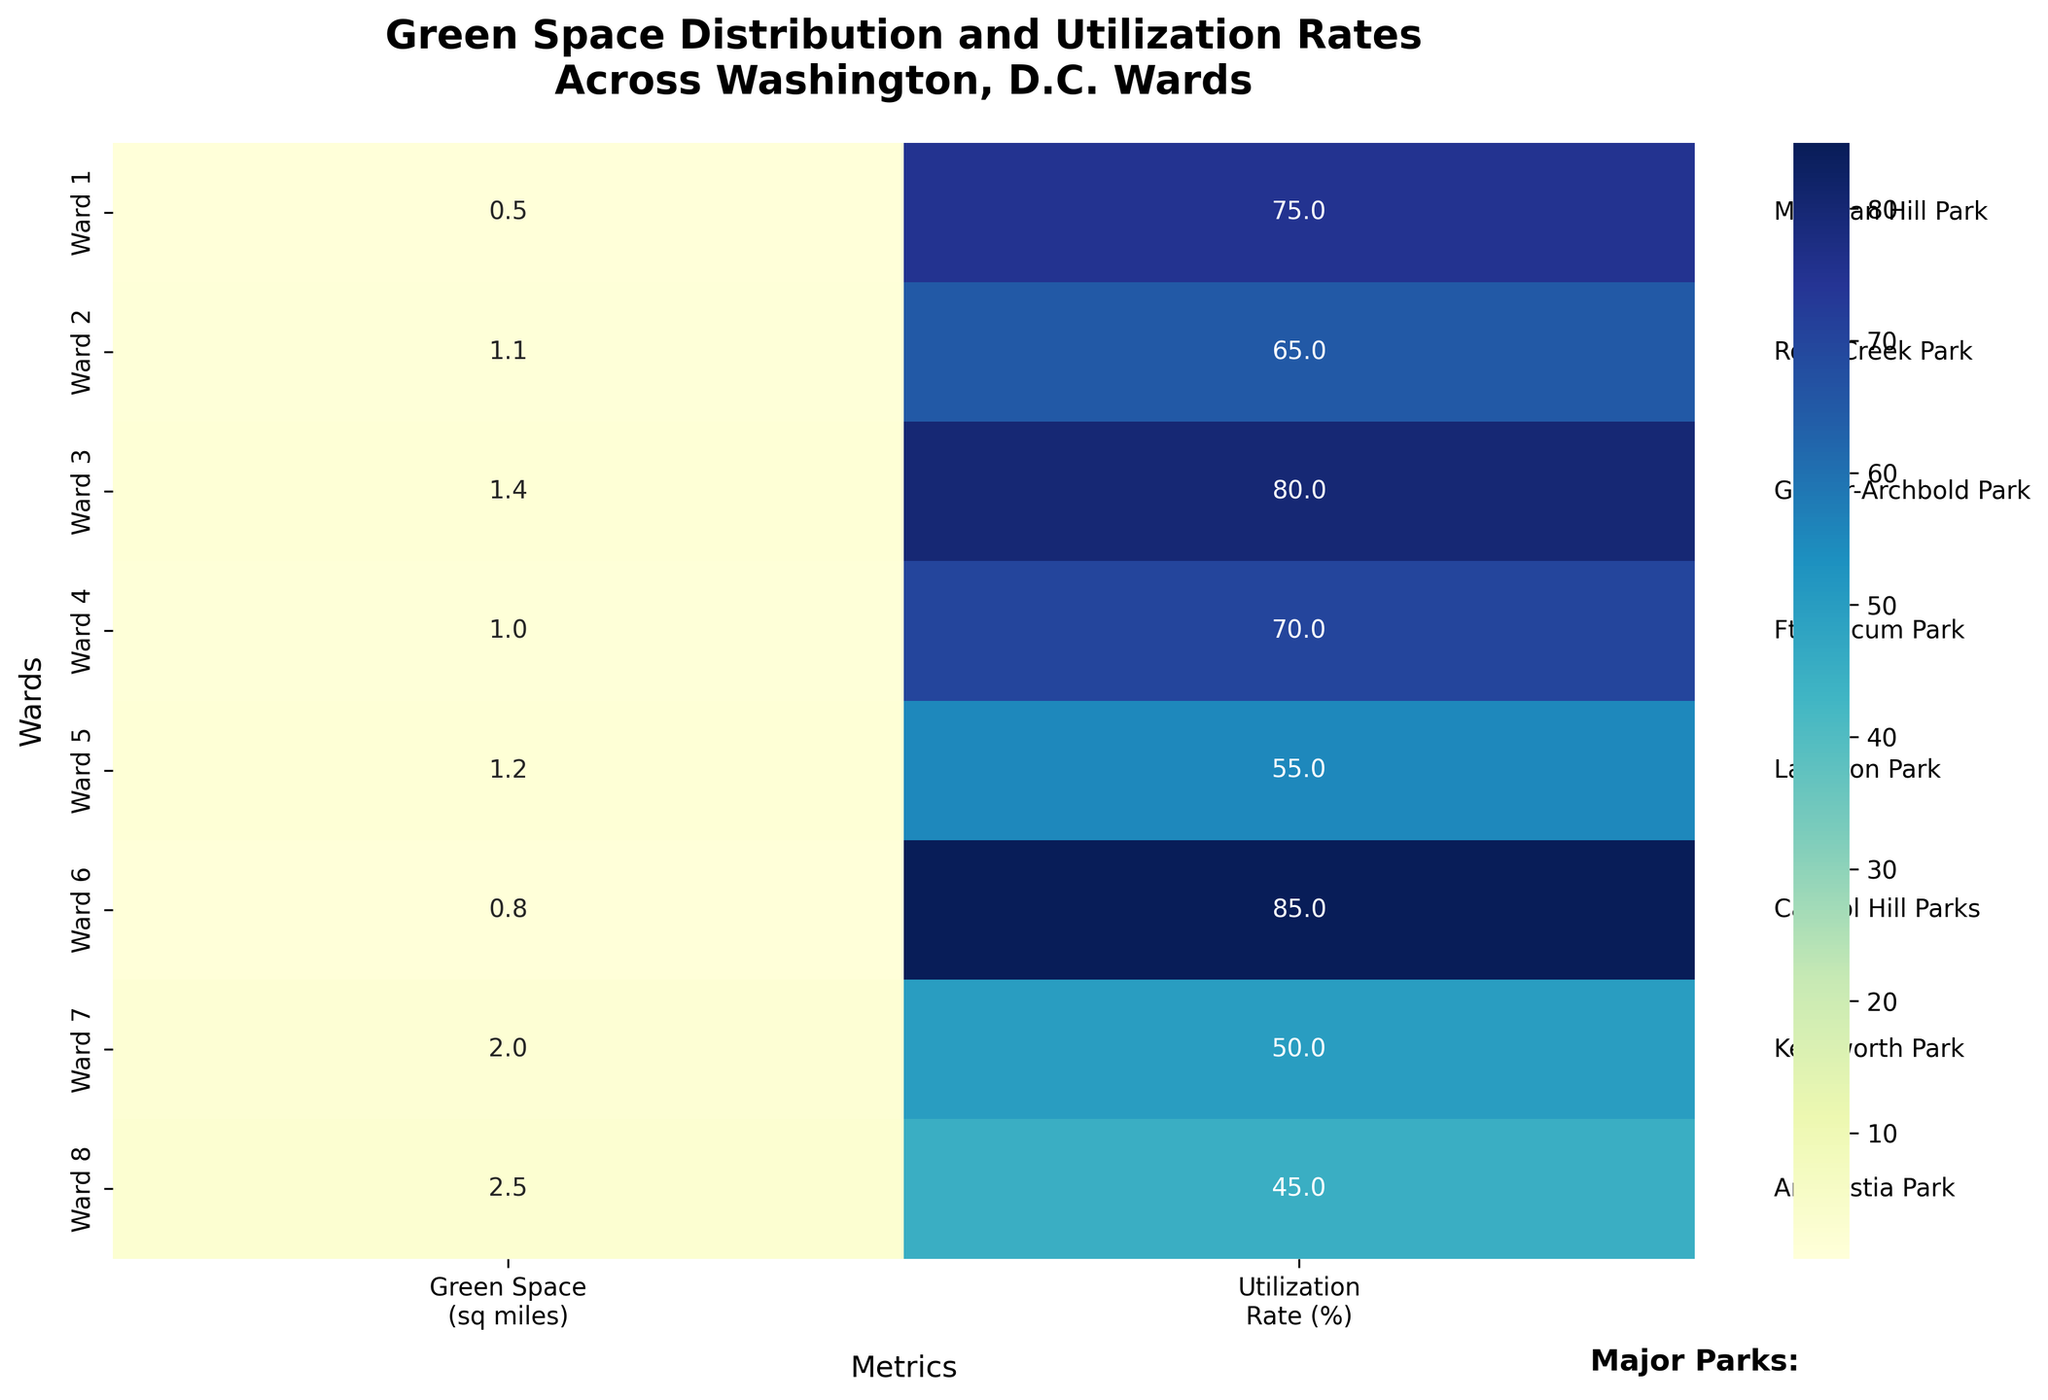Which ward has the largest green space? In the heatmap, look at the values under "Green Space (sq miles)" and find the highest number. Ward 8 has the largest green space with 2.5 sq miles.
Answer: Ward 8 Which ward has the highest utilization rate? Check the values under "Utilization Rate (%)" in the heatmap. Ward 6 has the highest utilization rate of 85%.
Answer: Ward 6 What is the average green space across all wards? Sum the green space values and divide by the number of wards: (0.5 + 1.1 + 1.4 + 1.0 + 1.2 + 0.8 + 2.0 + 2.5) / 8 = 10.5 / 8 = 1.31 sq miles.
Answer: 1.31 sq miles Which ward has the lowest utilization rate for green spaces? Identify the lowest value under "Utilization Rate (%)" in the heatmap. Ward 8 has the lowest utilization rate of 45%.
Answer: Ward 8 Compare the utilization rates between Ward 3 and Ward 7. Which is higher? Look at the utilization rates for Ward 3 and Ward 7 in the heatmap. Ward 3 has an 80% utilization rate, while Ward 7 has a 50% utilization rate. Thus, Ward 3 is higher.
Answer: Ward 3 How does the green space of Ward 2 compare to that of Ward 5? Check the values under "Green Space (sq miles)" for both Ward 2 and Ward 5 in the heatmap. Ward 2 has 1.1 sq miles and Ward 5 has 1.2 sq miles of green space. Ward 5 has slightly more green space than Ward 2.
Answer: Ward 5 What is the total green space in Wards 4, 6, and 8 combined? Add the green space values for Wards 4, 6, and 8: 1.0 + 0.8 + 2.5 = 4.3 sq miles.
Answer: 4.3 sq miles Which ward has the park named Kenilworth Park? Based on the heatmap annotations and texts near the rows. Kenilworth Park is in Ward 7.
Answer: Ward 7 How many wards have more than 1.0 sq mile of green space? Identify wards with green space values greater than 1.0: Wards 2, 3, 5, 7, and 8 have more than 1.0 sq mile of green space. There are 5 such wards.
Answer: 5 Compare the utilization rate of Ward 1 to the combined average utilization rate of Ward 5 and Ward 8. Ward 1 has a utilization rate of 75%. The average utilization rate of Wards 5 and 8 is (55% + 45%) / 2 = 50%. Ward 1 has a higher utilization rate than the average combined rate of Wards 5 and 8.
Answer: Ward 1 